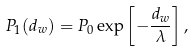<formula> <loc_0><loc_0><loc_500><loc_500>P _ { 1 } ( d _ { w } ) = P _ { 0 } \exp \left [ - \frac { d _ { w } } { \lambda } \right ] ,</formula> 